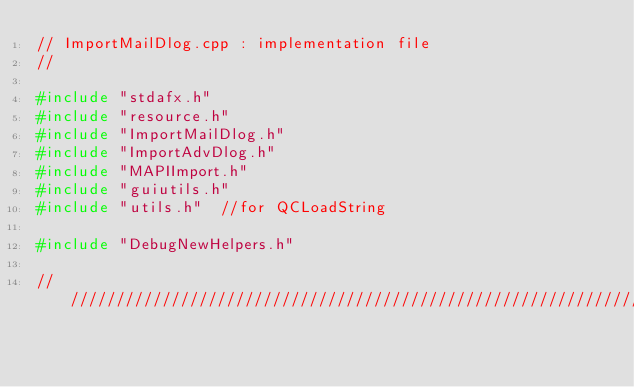<code> <loc_0><loc_0><loc_500><loc_500><_C++_>// ImportMailDlog.cpp : implementation file
//

#include "stdafx.h"
#include "resource.h"
#include "ImportMailDlog.h"
#include "ImportAdvDlog.h"
#include "MAPIImport.h"
#include "guiutils.h"
#include "utils.h"  //for QCLoadString

#include "DebugNewHelpers.h"

/////////////////////////////////////////////////////////////////////////////</code> 